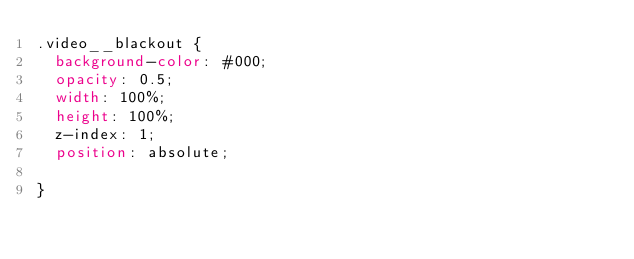Convert code to text. <code><loc_0><loc_0><loc_500><loc_500><_CSS_>.video__blackout {
	background-color: #000;
	opacity: 0.5;
	width: 100%;
	height: 100%;
	z-index: 1;
	position: absolute;
	
}</code> 